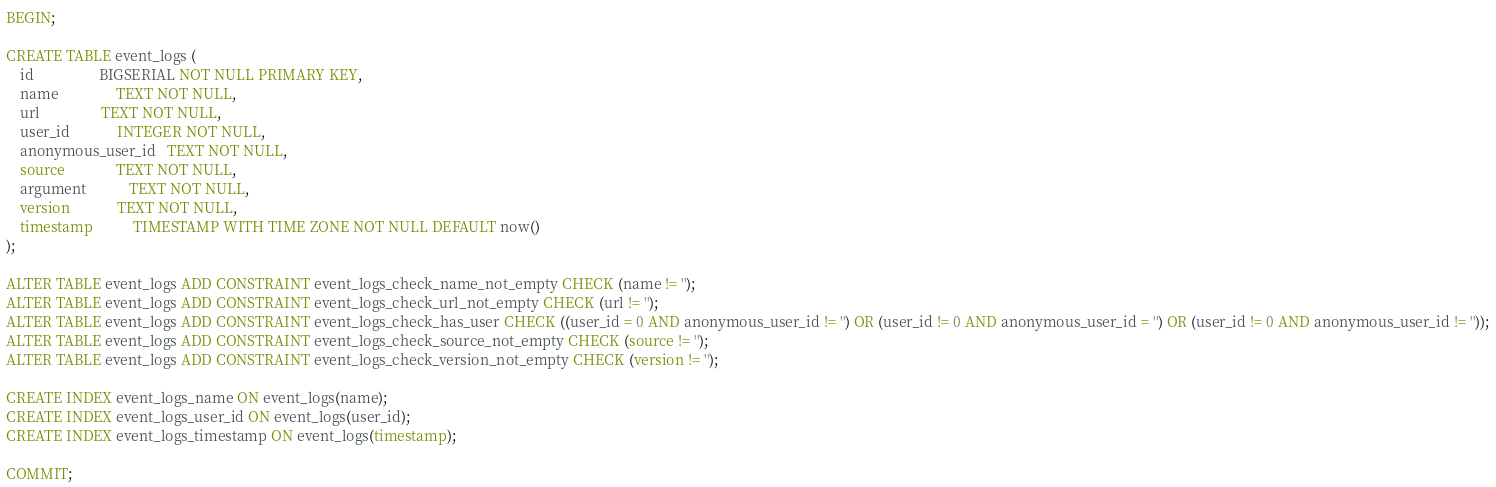Convert code to text. <code><loc_0><loc_0><loc_500><loc_500><_SQL_>BEGIN;

CREATE TABLE event_logs (
    id                  BIGSERIAL NOT NULL PRIMARY KEY,
    name                TEXT NOT NULL,
    url                 TEXT NOT NULL,
    user_id             INTEGER NOT NULL,
    anonymous_user_id   TEXT NOT NULL,
    source              TEXT NOT NULL,
    argument            TEXT NOT NULL,
    version             TEXT NOT NULL,
    timestamp           TIMESTAMP WITH TIME ZONE NOT NULL DEFAULT now()
);

ALTER TABLE event_logs ADD CONSTRAINT event_logs_check_name_not_empty CHECK (name != '');
ALTER TABLE event_logs ADD CONSTRAINT event_logs_check_url_not_empty CHECK (url != '');
ALTER TABLE event_logs ADD CONSTRAINT event_logs_check_has_user CHECK ((user_id = 0 AND anonymous_user_id != '') OR (user_id != 0 AND anonymous_user_id = '') OR (user_id != 0 AND anonymous_user_id != ''));
ALTER TABLE event_logs ADD CONSTRAINT event_logs_check_source_not_empty CHECK (source != '');
ALTER TABLE event_logs ADD CONSTRAINT event_logs_check_version_not_empty CHECK (version != '');

CREATE INDEX event_logs_name ON event_logs(name);
CREATE INDEX event_logs_user_id ON event_logs(user_id);
CREATE INDEX event_logs_timestamp ON event_logs(timestamp);

COMMIT;
</code> 